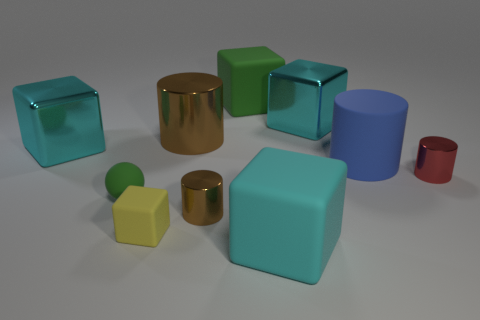Subtract all cyan cubes. How many were subtracted if there are1cyan cubes left? 2 Subtract all gray spheres. How many cyan cubes are left? 3 Subtract all yellow blocks. How many blocks are left? 4 Subtract all green matte blocks. How many blocks are left? 4 Subtract all red cubes. Subtract all cyan balls. How many cubes are left? 5 Subtract all spheres. How many objects are left? 9 Add 3 green metal things. How many green metal things exist? 3 Subtract 0 cyan cylinders. How many objects are left? 10 Subtract all small red shiny objects. Subtract all cubes. How many objects are left? 4 Add 5 big rubber things. How many big rubber things are left? 8 